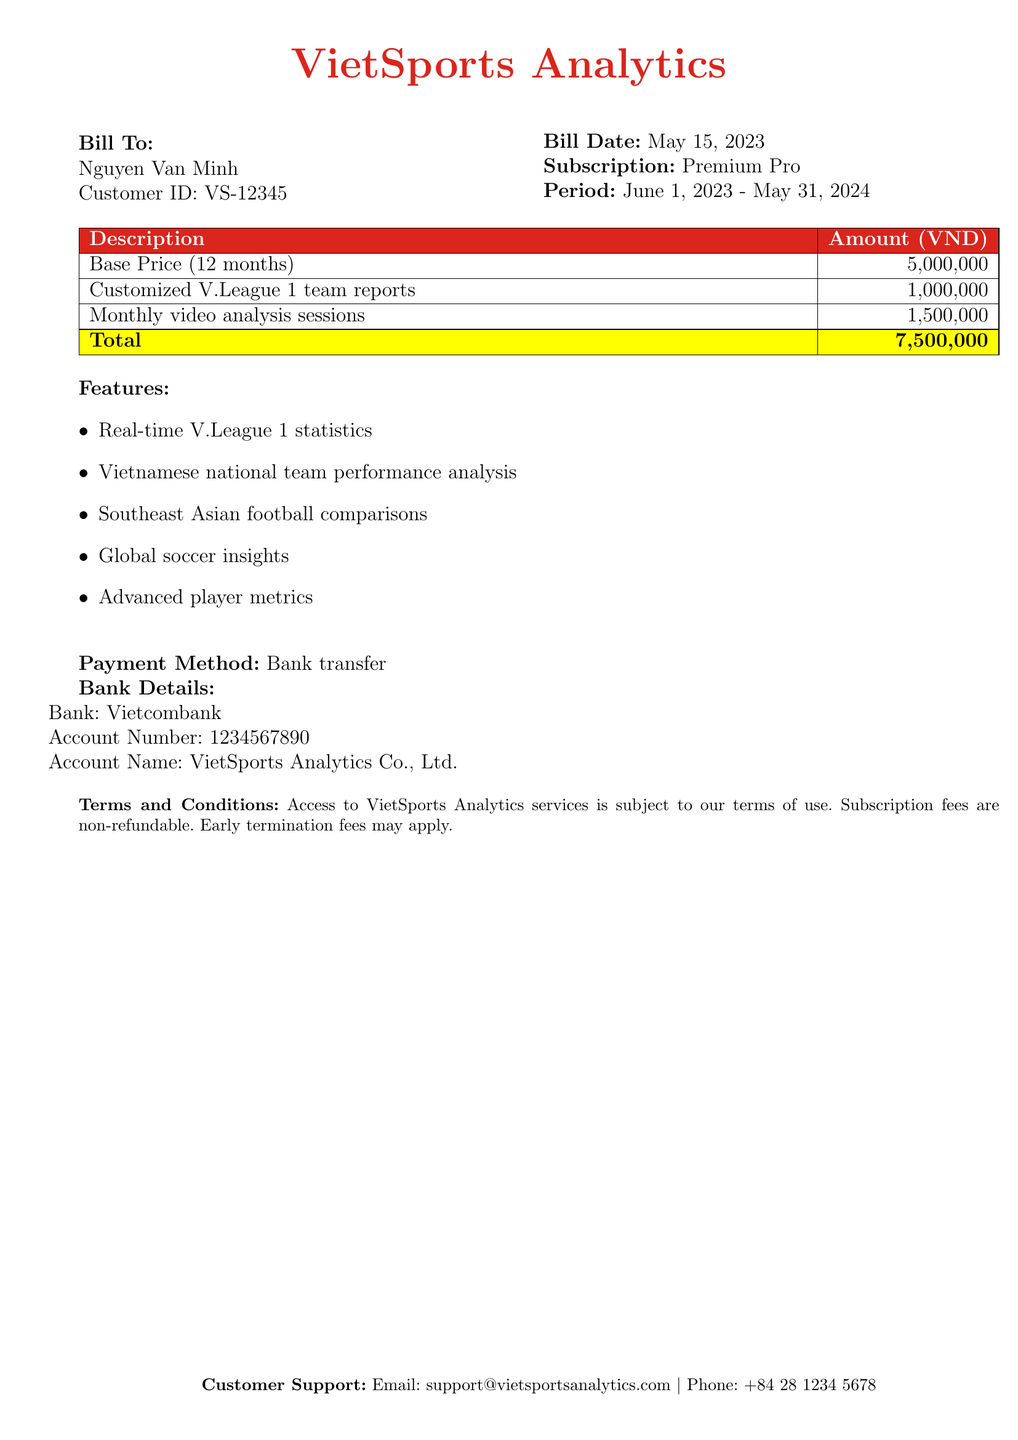What is the total amount for this subscription bill? The total amount is calculated by summing up the base price, customized reports, and video analysis sessions listed in the bill.
Answer: 7,500,000 VND Who is the bill addressed to? The recipient of the bill, as stated in the document, is Nguyen Van Minh.
Answer: Nguyen Van Minh What is the subscription period? The subscription period is clearly mentioned in the document, detailing the start and end dates.
Answer: June 1, 2023 - May 31, 2024 What is included in the base price? The base price covers the first twelve months of the subscription, specifically mentioned in the document.
Answer: 5,000,000 VND Which payment method is accepted? The accepted payment method for the subscription bill is specified in the bill's details.
Answer: Bank transfer What are the features provided in the subscription? The document lists several features included in the subscription services offered.
Answer: Real-time V.League 1 statistics What bank is mentioned for payment? The bank details provided for payment specify the name of the bank to be used.
Answer: Vietcombank What is the customer support email? The document provides a customer support email for queries related to the subscription.
Answer: support@vietsportsanalytics.com 